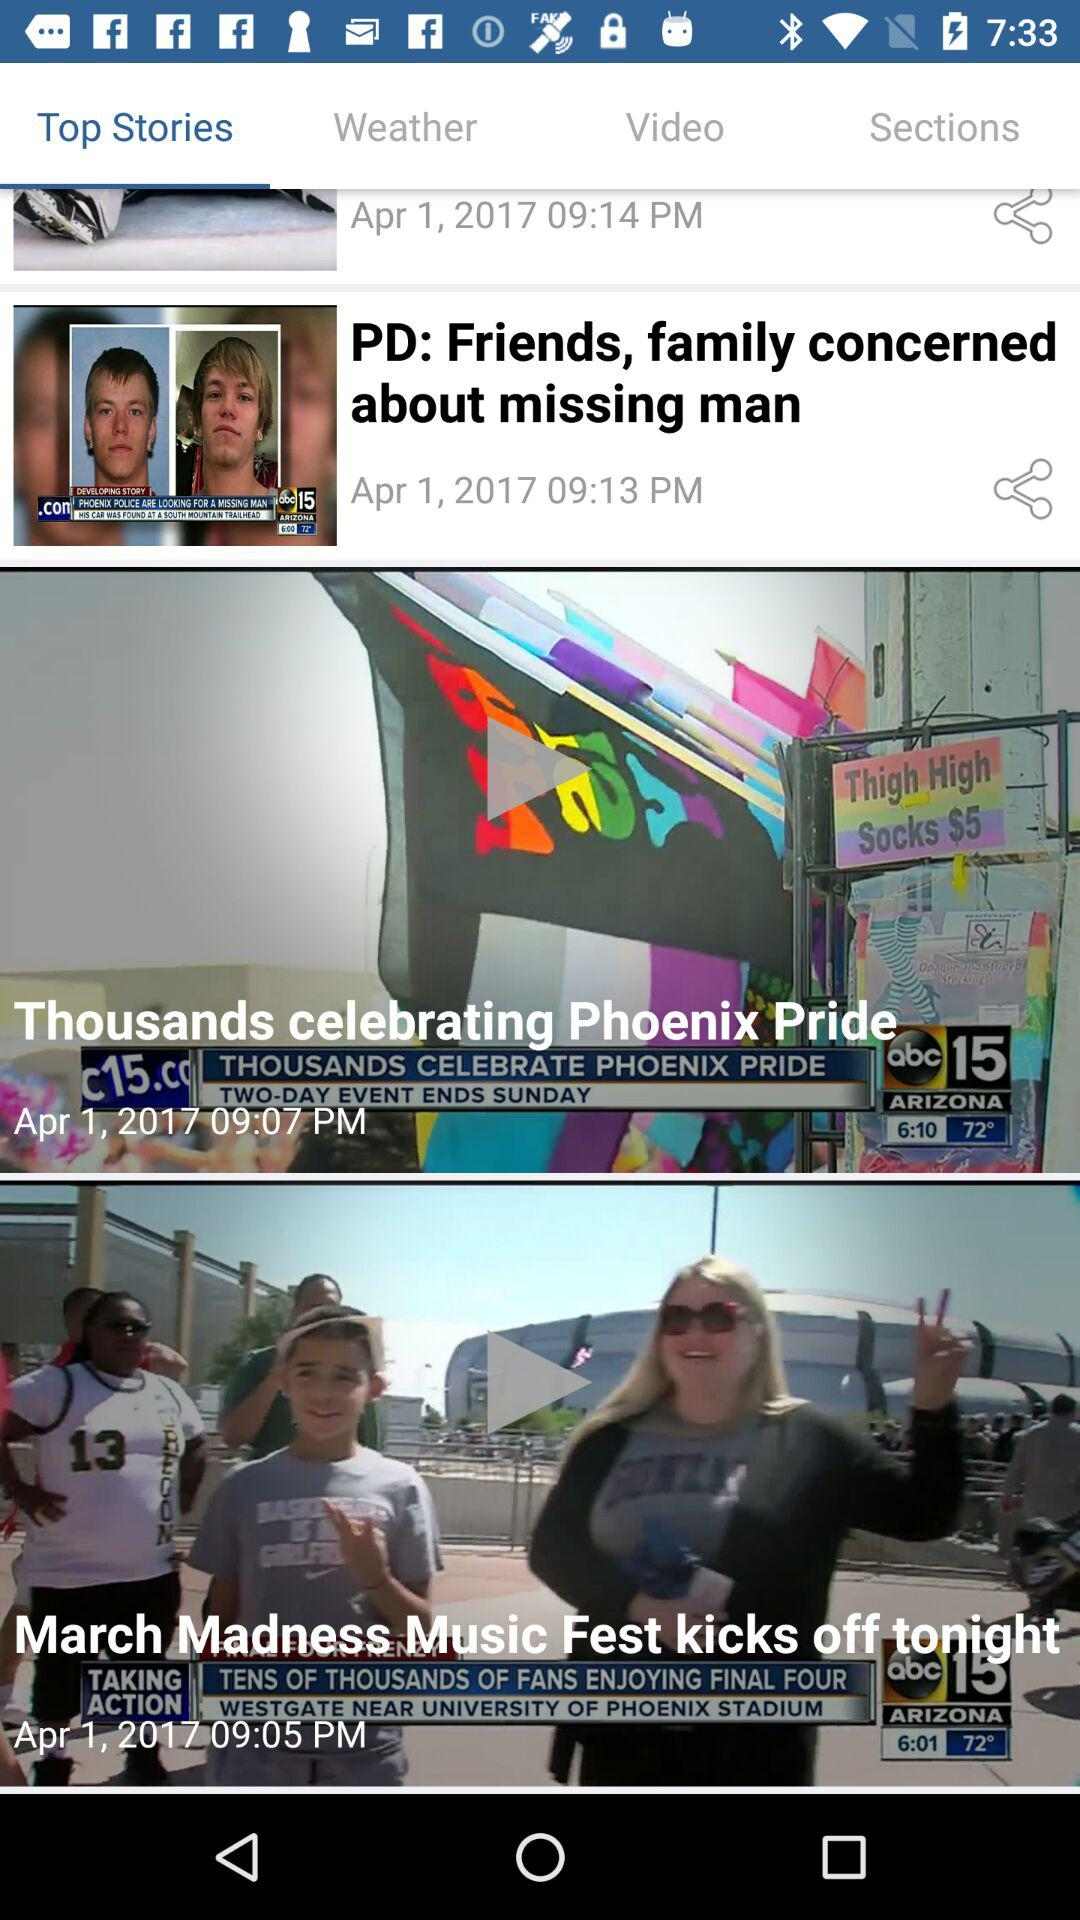Which tab is selected? The selected tab is "Top Stories". 